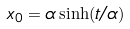<formula> <loc_0><loc_0><loc_500><loc_500>x _ { 0 } = \alpha \sinh ( t / \alpha )</formula> 